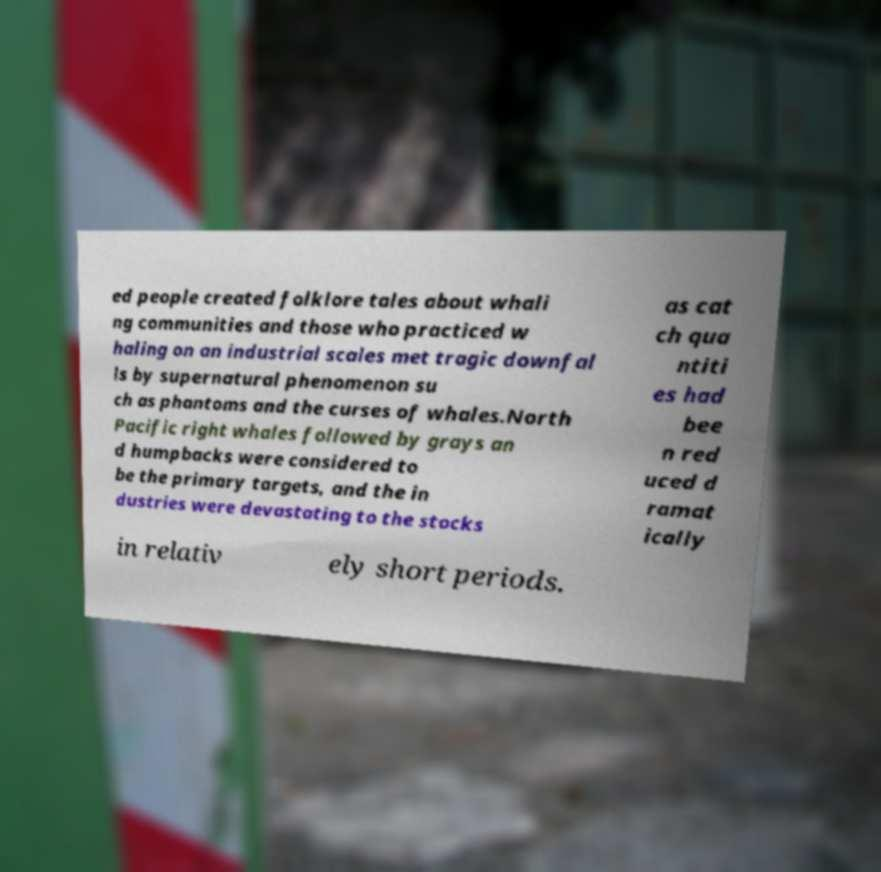Please read and relay the text visible in this image. What does it say? ed people created folklore tales about whali ng communities and those who practiced w haling on an industrial scales met tragic downfal ls by supernatural phenomenon su ch as phantoms and the curses of whales.North Pacific right whales followed by grays an d humpbacks were considered to be the primary targets, and the in dustries were devastating to the stocks as cat ch qua ntiti es had bee n red uced d ramat ically in relativ ely short periods. 